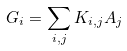Convert formula to latex. <formula><loc_0><loc_0><loc_500><loc_500>G _ { i } = \sum _ { i , j } K _ { i , j } A _ { j }</formula> 